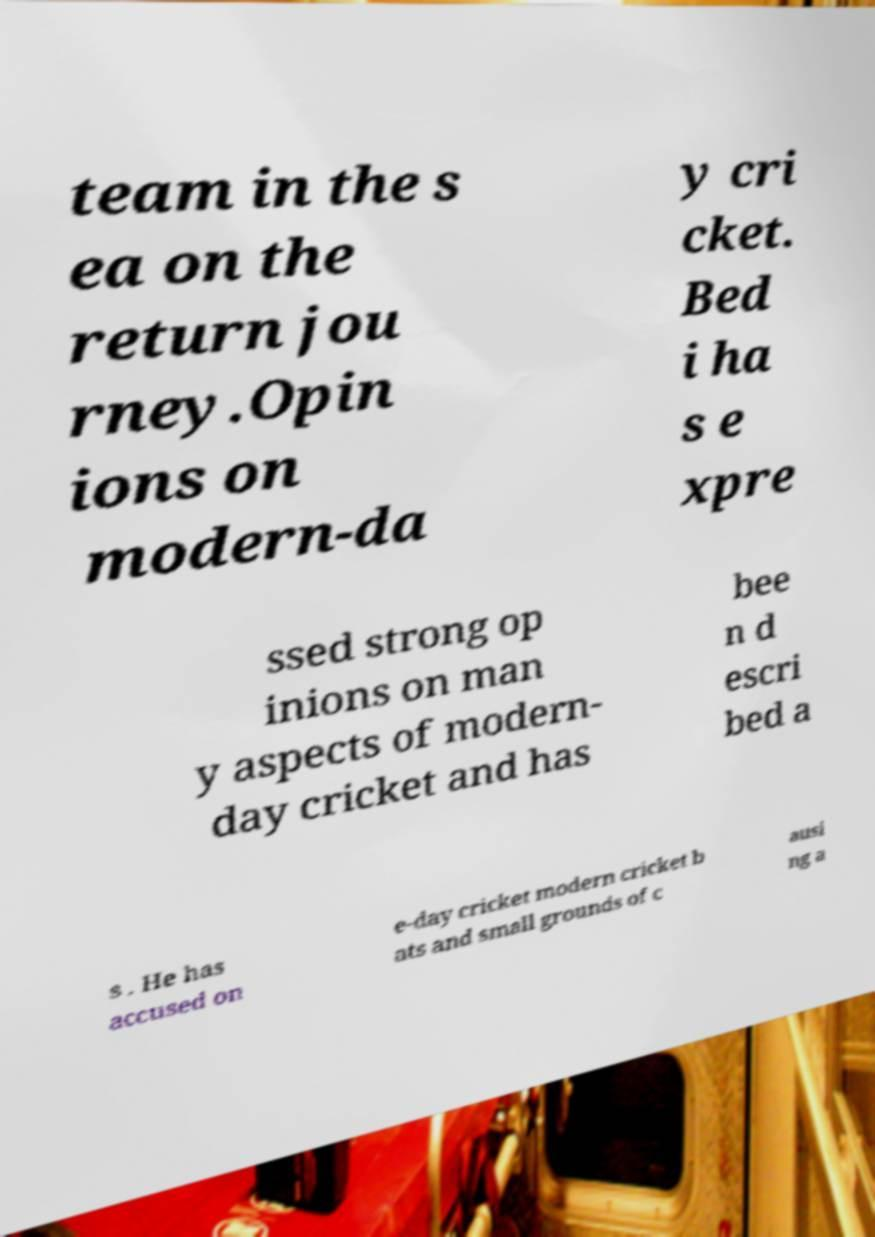What messages or text are displayed in this image? I need them in a readable, typed format. team in the s ea on the return jou rney.Opin ions on modern-da y cri cket. Bed i ha s e xpre ssed strong op inions on man y aspects of modern- day cricket and has bee n d escri bed a s . He has accused on e-day cricket modern cricket b ats and small grounds of c ausi ng a 